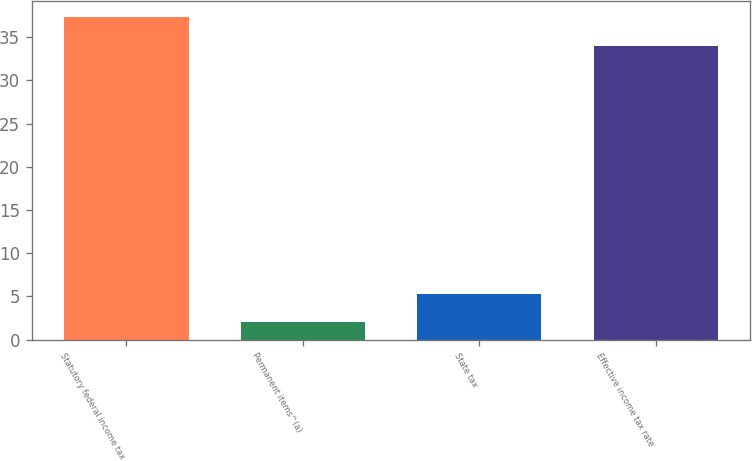<chart> <loc_0><loc_0><loc_500><loc_500><bar_chart><fcel>Statutory federal income tax<fcel>Permanent items^(a)<fcel>State tax<fcel>Effective income tax rate<nl><fcel>37.3<fcel>2<fcel>5.3<fcel>34<nl></chart> 